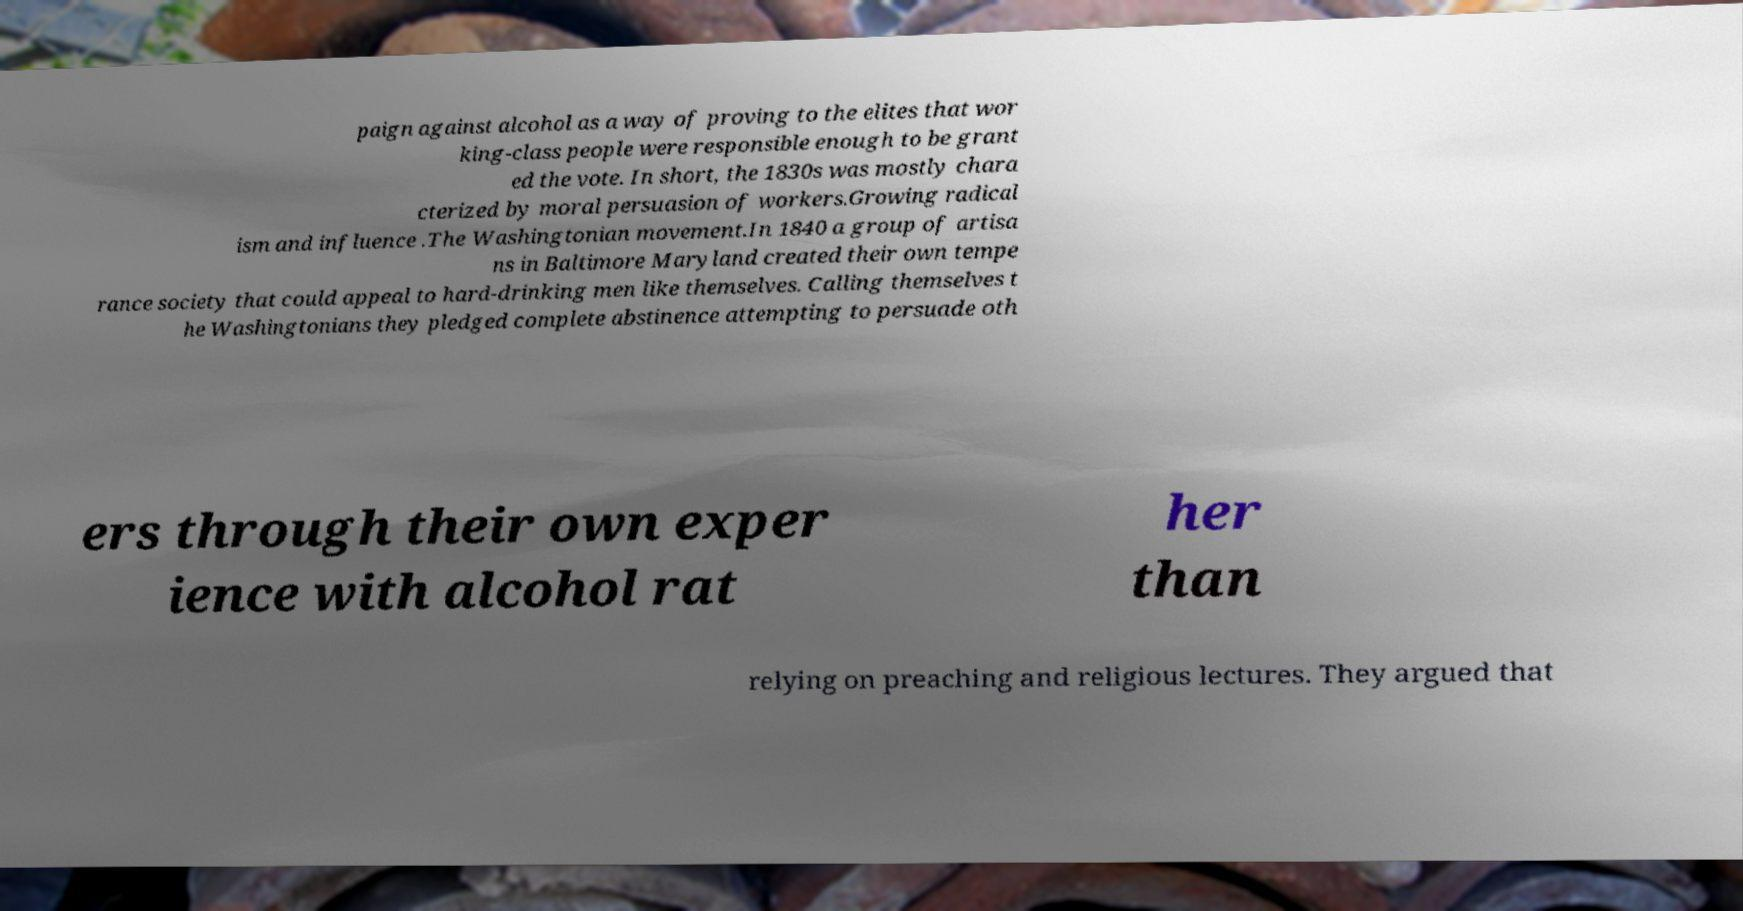Can you accurately transcribe the text from the provided image for me? paign against alcohol as a way of proving to the elites that wor king-class people were responsible enough to be grant ed the vote. In short, the 1830s was mostly chara cterized by moral persuasion of workers.Growing radical ism and influence .The Washingtonian movement.In 1840 a group of artisa ns in Baltimore Maryland created their own tempe rance society that could appeal to hard-drinking men like themselves. Calling themselves t he Washingtonians they pledged complete abstinence attempting to persuade oth ers through their own exper ience with alcohol rat her than relying on preaching and religious lectures. They argued that 